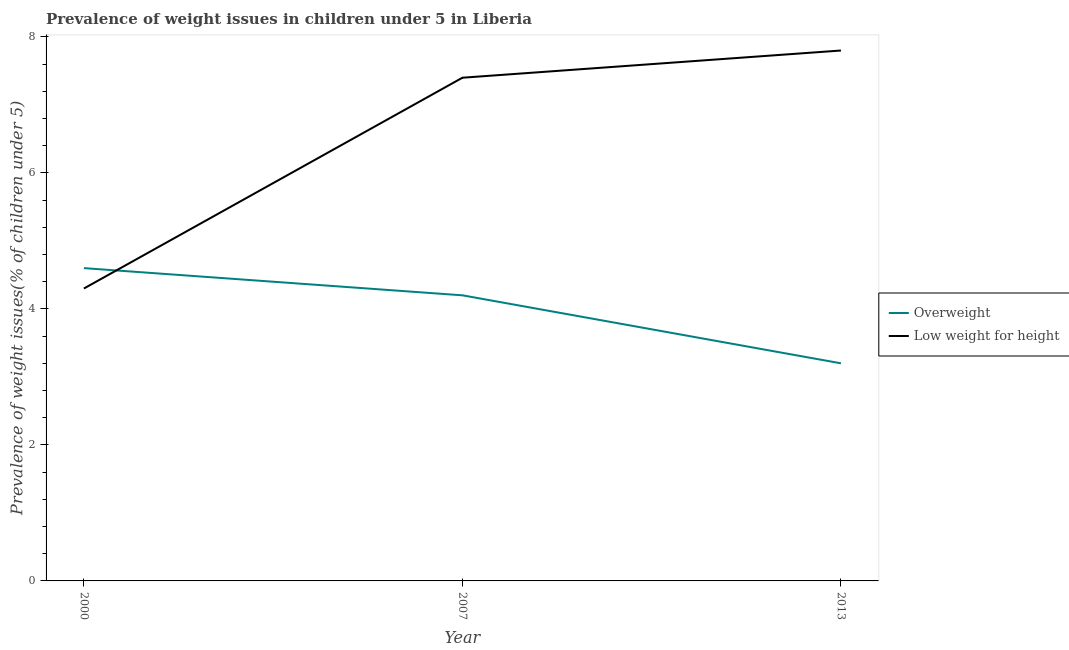How many different coloured lines are there?
Keep it short and to the point. 2. Does the line corresponding to percentage of underweight children intersect with the line corresponding to percentage of overweight children?
Your response must be concise. Yes. What is the percentage of overweight children in 2013?
Your answer should be very brief. 3.2. Across all years, what is the maximum percentage of underweight children?
Make the answer very short. 7.8. Across all years, what is the minimum percentage of underweight children?
Provide a succinct answer. 4.3. What is the total percentage of underweight children in the graph?
Your response must be concise. 19.5. What is the difference between the percentage of underweight children in 2007 and that in 2013?
Offer a very short reply. -0.4. What is the difference between the percentage of overweight children in 2007 and the percentage of underweight children in 2000?
Your answer should be compact. -0.1. What is the average percentage of overweight children per year?
Offer a very short reply. 4. In the year 2013, what is the difference between the percentage of underweight children and percentage of overweight children?
Your answer should be very brief. 4.6. What is the ratio of the percentage of underweight children in 2000 to that in 2007?
Ensure brevity in your answer.  0.58. Is the difference between the percentage of overweight children in 2000 and 2013 greater than the difference between the percentage of underweight children in 2000 and 2013?
Provide a short and direct response. Yes. What is the difference between the highest and the second highest percentage of underweight children?
Keep it short and to the point. 0.4. What is the difference between the highest and the lowest percentage of underweight children?
Offer a terse response. 3.5. In how many years, is the percentage of underweight children greater than the average percentage of underweight children taken over all years?
Your answer should be compact. 2. Is the sum of the percentage of overweight children in 2000 and 2007 greater than the maximum percentage of underweight children across all years?
Ensure brevity in your answer.  Yes. Is the percentage of overweight children strictly less than the percentage of underweight children over the years?
Offer a very short reply. No. How many lines are there?
Give a very brief answer. 2. What is the difference between two consecutive major ticks on the Y-axis?
Your answer should be compact. 2. Are the values on the major ticks of Y-axis written in scientific E-notation?
Your answer should be very brief. No. Does the graph contain any zero values?
Give a very brief answer. No. Does the graph contain grids?
Offer a terse response. No. What is the title of the graph?
Provide a succinct answer. Prevalence of weight issues in children under 5 in Liberia. Does "Highest 10% of population" appear as one of the legend labels in the graph?
Your answer should be compact. No. What is the label or title of the X-axis?
Your answer should be very brief. Year. What is the label or title of the Y-axis?
Make the answer very short. Prevalence of weight issues(% of children under 5). What is the Prevalence of weight issues(% of children under 5) of Overweight in 2000?
Offer a very short reply. 4.6. What is the Prevalence of weight issues(% of children under 5) of Low weight for height in 2000?
Provide a succinct answer. 4.3. What is the Prevalence of weight issues(% of children under 5) in Overweight in 2007?
Provide a short and direct response. 4.2. What is the Prevalence of weight issues(% of children under 5) of Low weight for height in 2007?
Offer a terse response. 7.4. What is the Prevalence of weight issues(% of children under 5) in Overweight in 2013?
Provide a short and direct response. 3.2. What is the Prevalence of weight issues(% of children under 5) in Low weight for height in 2013?
Your response must be concise. 7.8. Across all years, what is the maximum Prevalence of weight issues(% of children under 5) in Overweight?
Keep it short and to the point. 4.6. Across all years, what is the maximum Prevalence of weight issues(% of children under 5) in Low weight for height?
Your response must be concise. 7.8. Across all years, what is the minimum Prevalence of weight issues(% of children under 5) of Overweight?
Ensure brevity in your answer.  3.2. Across all years, what is the minimum Prevalence of weight issues(% of children under 5) of Low weight for height?
Provide a succinct answer. 4.3. What is the total Prevalence of weight issues(% of children under 5) of Overweight in the graph?
Offer a very short reply. 12. What is the total Prevalence of weight issues(% of children under 5) of Low weight for height in the graph?
Keep it short and to the point. 19.5. What is the difference between the Prevalence of weight issues(% of children under 5) in Overweight in 2000 and that in 2007?
Provide a short and direct response. 0.4. What is the difference between the Prevalence of weight issues(% of children under 5) in Low weight for height in 2000 and that in 2007?
Ensure brevity in your answer.  -3.1. What is the difference between the Prevalence of weight issues(% of children under 5) in Low weight for height in 2000 and that in 2013?
Offer a terse response. -3.5. What is the difference between the Prevalence of weight issues(% of children under 5) in Overweight in 2007 and that in 2013?
Offer a terse response. 1. What is the average Prevalence of weight issues(% of children under 5) in Low weight for height per year?
Your answer should be compact. 6.5. In the year 2000, what is the difference between the Prevalence of weight issues(% of children under 5) in Overweight and Prevalence of weight issues(% of children under 5) in Low weight for height?
Ensure brevity in your answer.  0.3. In the year 2013, what is the difference between the Prevalence of weight issues(% of children under 5) of Overweight and Prevalence of weight issues(% of children under 5) of Low weight for height?
Offer a very short reply. -4.6. What is the ratio of the Prevalence of weight issues(% of children under 5) in Overweight in 2000 to that in 2007?
Ensure brevity in your answer.  1.1. What is the ratio of the Prevalence of weight issues(% of children under 5) of Low weight for height in 2000 to that in 2007?
Offer a very short reply. 0.58. What is the ratio of the Prevalence of weight issues(% of children under 5) of Overweight in 2000 to that in 2013?
Offer a terse response. 1.44. What is the ratio of the Prevalence of weight issues(% of children under 5) of Low weight for height in 2000 to that in 2013?
Your answer should be very brief. 0.55. What is the ratio of the Prevalence of weight issues(% of children under 5) in Overweight in 2007 to that in 2013?
Keep it short and to the point. 1.31. What is the ratio of the Prevalence of weight issues(% of children under 5) of Low weight for height in 2007 to that in 2013?
Make the answer very short. 0.95. What is the difference between the highest and the second highest Prevalence of weight issues(% of children under 5) in Overweight?
Your answer should be very brief. 0.4. What is the difference between the highest and the second highest Prevalence of weight issues(% of children under 5) in Low weight for height?
Your answer should be compact. 0.4. What is the difference between the highest and the lowest Prevalence of weight issues(% of children under 5) in Overweight?
Provide a succinct answer. 1.4. What is the difference between the highest and the lowest Prevalence of weight issues(% of children under 5) of Low weight for height?
Provide a succinct answer. 3.5. 